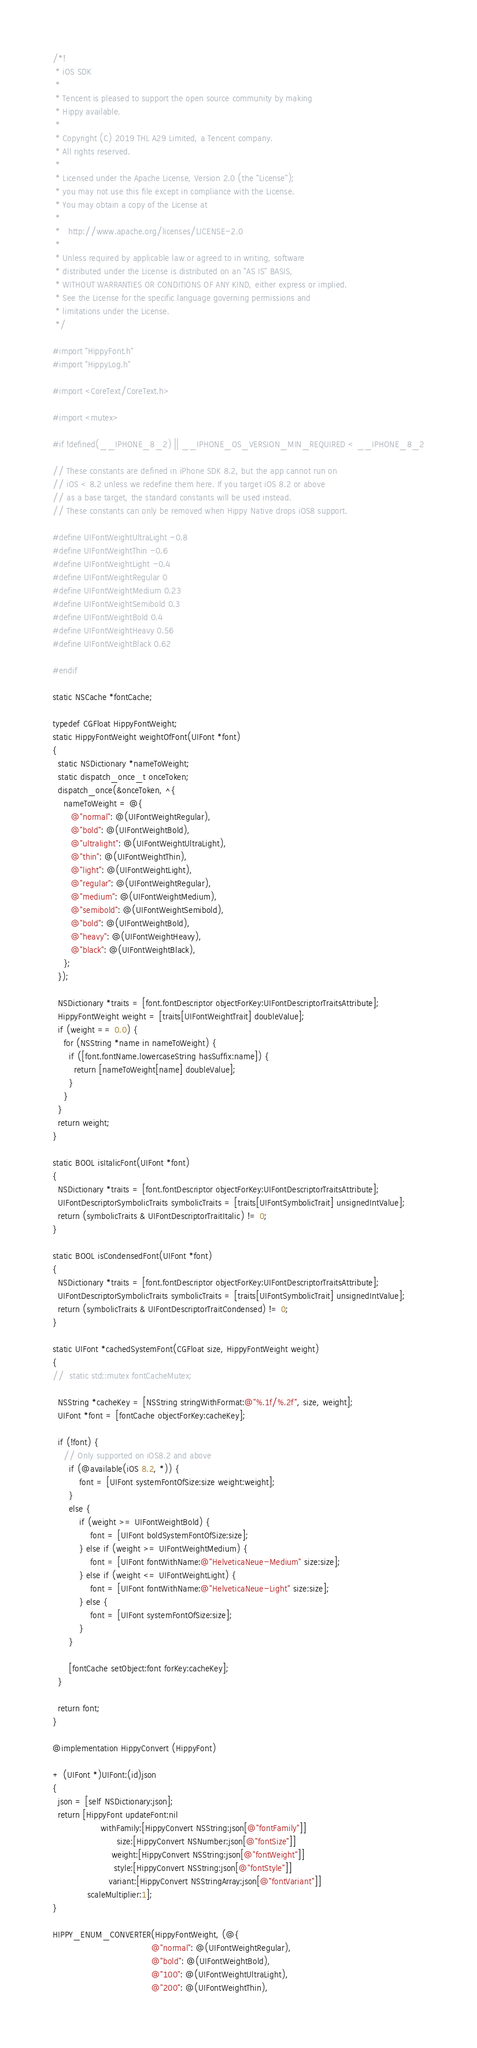Convert code to text. <code><loc_0><loc_0><loc_500><loc_500><_ObjectiveC_>/*!
 * iOS SDK
 *
 * Tencent is pleased to support the open source community by making
 * Hippy available.
 *
 * Copyright (C) 2019 THL A29 Limited, a Tencent company.
 * All rights reserved.
 *
 * Licensed under the Apache License, Version 2.0 (the "License");
 * you may not use this file except in compliance with the License.
 * You may obtain a copy of the License at
 *
 *   http://www.apache.org/licenses/LICENSE-2.0
 *
 * Unless required by applicable law or agreed to in writing, software
 * distributed under the License is distributed on an "AS IS" BASIS,
 * WITHOUT WARRANTIES OR CONDITIONS OF ANY KIND, either express or implied.
 * See the License for the specific language governing permissions and
 * limitations under the License.
 */

#import "HippyFont.h"
#import "HippyLog.h"

#import <CoreText/CoreText.h>

#import <mutex>

#if !defined(__IPHONE_8_2) || __IPHONE_OS_VERSION_MIN_REQUIRED < __IPHONE_8_2

// These constants are defined in iPhone SDK 8.2, but the app cannot run on
// iOS < 8.2 unless we redefine them here. If you target iOS 8.2 or above
// as a base target, the standard constants will be used instead.
// These constants can only be removed when Hippy Native drops iOS8 support.

#define UIFontWeightUltraLight -0.8
#define UIFontWeightThin -0.6
#define UIFontWeightLight -0.4
#define UIFontWeightRegular 0
#define UIFontWeightMedium 0.23
#define UIFontWeightSemibold 0.3
#define UIFontWeightBold 0.4
#define UIFontWeightHeavy 0.56
#define UIFontWeightBlack 0.62

#endif

static NSCache *fontCache;

typedef CGFloat HippyFontWeight;
static HippyFontWeight weightOfFont(UIFont *font)
{
  static NSDictionary *nameToWeight;
  static dispatch_once_t onceToken;
  dispatch_once(&onceToken, ^{
    nameToWeight = @{
       @"normal": @(UIFontWeightRegular),
       @"bold": @(UIFontWeightBold),
       @"ultralight": @(UIFontWeightUltraLight),
       @"thin": @(UIFontWeightThin),
       @"light": @(UIFontWeightLight),
       @"regular": @(UIFontWeightRegular),
       @"medium": @(UIFontWeightMedium),
       @"semibold": @(UIFontWeightSemibold),
       @"bold": @(UIFontWeightBold),
       @"heavy": @(UIFontWeightHeavy),
       @"black": @(UIFontWeightBlack),
    };
  });

  NSDictionary *traits = [font.fontDescriptor objectForKey:UIFontDescriptorTraitsAttribute];
  HippyFontWeight weight = [traits[UIFontWeightTrait] doubleValue];
  if (weight == 0.0) {
    for (NSString *name in nameToWeight) {
      if ([font.fontName.lowercaseString hasSuffix:name]) {
        return [nameToWeight[name] doubleValue];
      }
    }
  }
  return weight;
}

static BOOL isItalicFont(UIFont *font)
{
  NSDictionary *traits = [font.fontDescriptor objectForKey:UIFontDescriptorTraitsAttribute];
  UIFontDescriptorSymbolicTraits symbolicTraits = [traits[UIFontSymbolicTrait] unsignedIntValue];
  return (symbolicTraits & UIFontDescriptorTraitItalic) != 0;
}

static BOOL isCondensedFont(UIFont *font)
{
  NSDictionary *traits = [font.fontDescriptor objectForKey:UIFontDescriptorTraitsAttribute];
  UIFontDescriptorSymbolicTraits symbolicTraits = [traits[UIFontSymbolicTrait] unsignedIntValue];
  return (symbolicTraits & UIFontDescriptorTraitCondensed) != 0;
}

static UIFont *cachedSystemFont(CGFloat size, HippyFontWeight weight)
{
//  static std::mutex fontCacheMutex;

  NSString *cacheKey = [NSString stringWithFormat:@"%.1f/%.2f", size, weight];
  UIFont *font = [fontCache objectForKey:cacheKey];

  if (!font) {
    // Only supported on iOS8.2 and above
      if (@available(iOS 8.2, *)) {
          font = [UIFont systemFontOfSize:size weight:weight];
      }
      else {
          if (weight >= UIFontWeightBold) {
              font = [UIFont boldSystemFontOfSize:size];
          } else if (weight >= UIFontWeightMedium) {
              font = [UIFont fontWithName:@"HelveticaNeue-Medium" size:size];
          } else if (weight <= UIFontWeightLight) {
              font = [UIFont fontWithName:@"HelveticaNeue-Light" size:size];
          } else {
              font = [UIFont systemFontOfSize:size];
          }
      }

      [fontCache setObject:font forKey:cacheKey];
  }

  return font;
}

@implementation HippyConvert (HippyFont)

+ (UIFont *)UIFont:(id)json
{
  json = [self NSDictionary:json];
  return [HippyFont updateFont:nil
                  withFamily:[HippyConvert NSString:json[@"fontFamily"]]
                        size:[HippyConvert NSNumber:json[@"fontSize"]]
                      weight:[HippyConvert NSString:json[@"fontWeight"]]
                       style:[HippyConvert NSString:json[@"fontStyle"]]
                     variant:[HippyConvert NSStringArray:json[@"fontVariant"]]
             scaleMultiplier:1];
}

HIPPY_ENUM_CONVERTER(HippyFontWeight, (@{
                                     @"normal": @(UIFontWeightRegular),
                                     @"bold": @(UIFontWeightBold),
                                     @"100": @(UIFontWeightUltraLight),
                                     @"200": @(UIFontWeightThin),</code> 